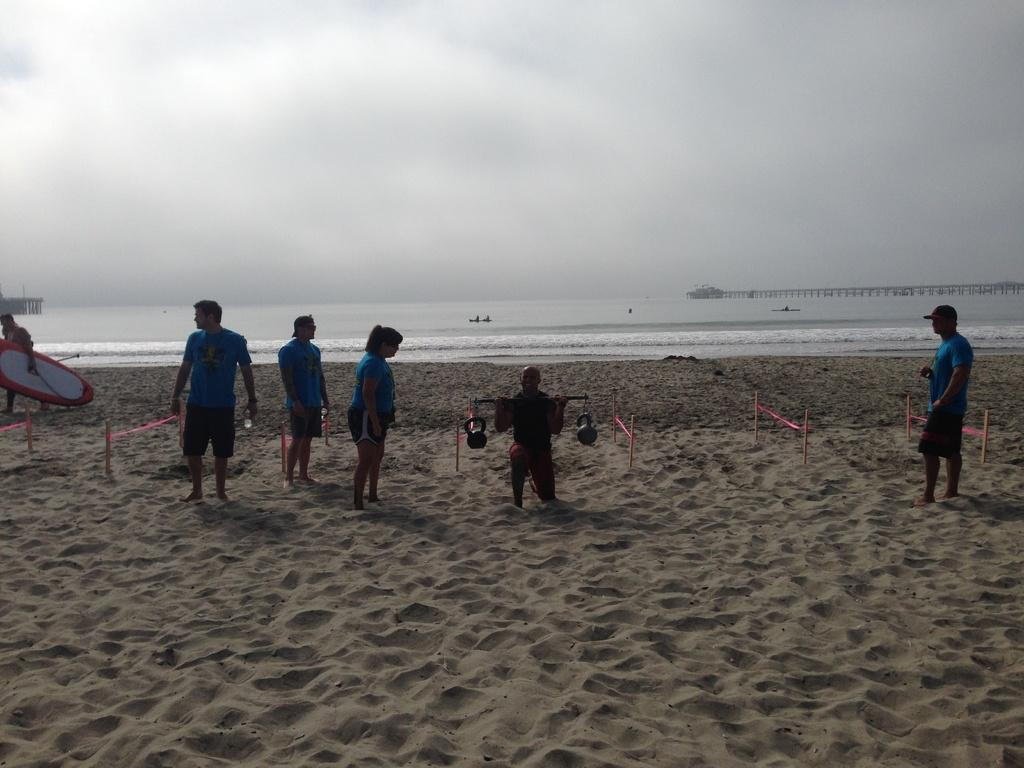What is the main subject of the image? The main subject of the image is people standing. What type of terrain is visible in the image? The image depicts sand. What else can be seen in the image besides people and sand? There is water visible in the image. What is visible in the background of the image? The sky is visible in the image. What activity is one of the people engaged in? There is a person lifting a weight in the image. What type of pickle is being used as a ball in the image? There is no pickle or ball present in the image. Is there any blood visible in the image? There is no blood visible in the image. 